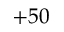Convert formula to latex. <formula><loc_0><loc_0><loc_500><loc_500>+ 5 0</formula> 